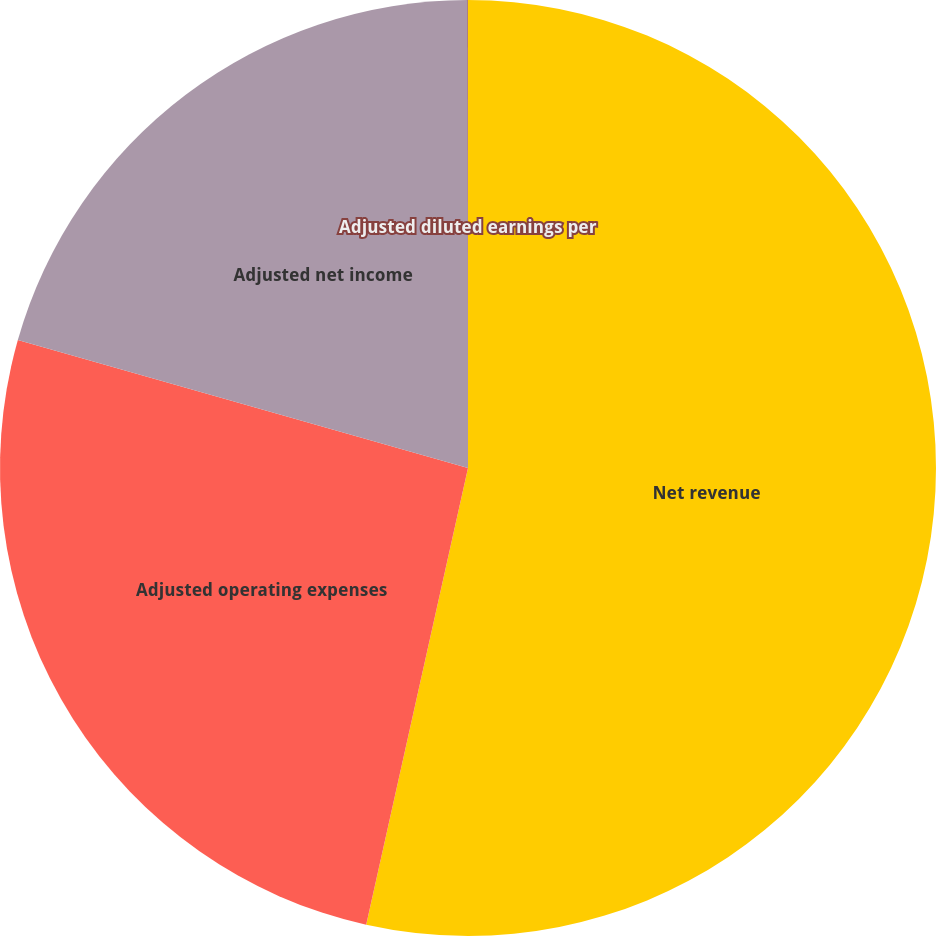Convert chart. <chart><loc_0><loc_0><loc_500><loc_500><pie_chart><fcel>Net revenue<fcel>Adjusted operating expenses<fcel>Adjusted net income<fcel>Adjusted diluted earnings per<nl><fcel>53.49%<fcel>25.92%<fcel>20.57%<fcel>0.02%<nl></chart> 